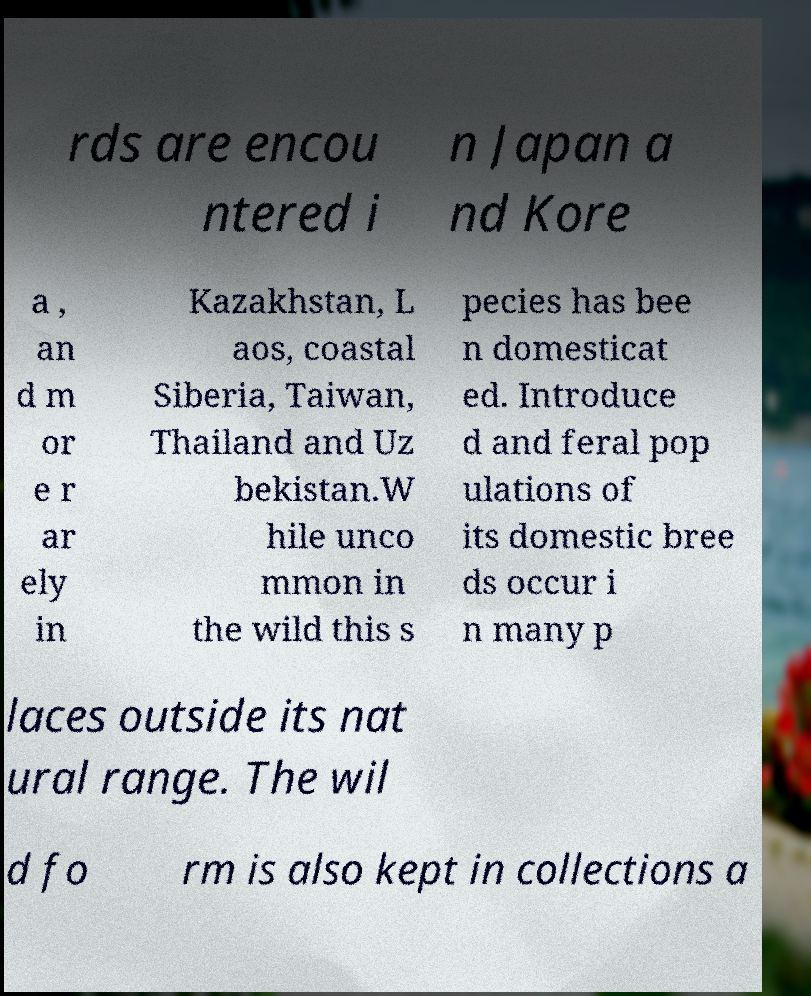What messages or text are displayed in this image? I need them in a readable, typed format. rds are encou ntered i n Japan a nd Kore a , an d m or e r ar ely in Kazakhstan, L aos, coastal Siberia, Taiwan, Thailand and Uz bekistan.W hile unco mmon in the wild this s pecies has bee n domesticat ed. Introduce d and feral pop ulations of its domestic bree ds occur i n many p laces outside its nat ural range. The wil d fo rm is also kept in collections a 